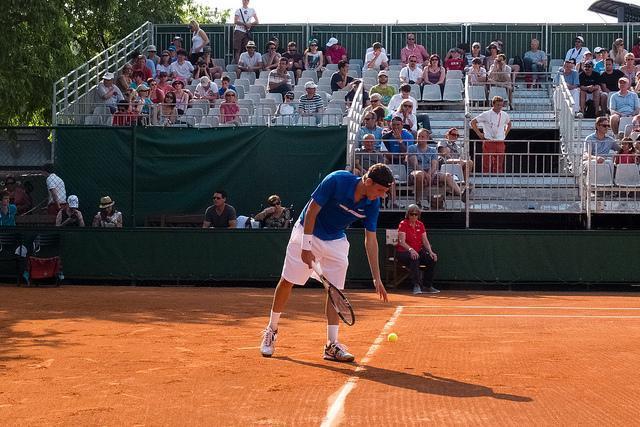How many people are there?
Give a very brief answer. 2. How many cars can be seen?
Give a very brief answer. 0. 